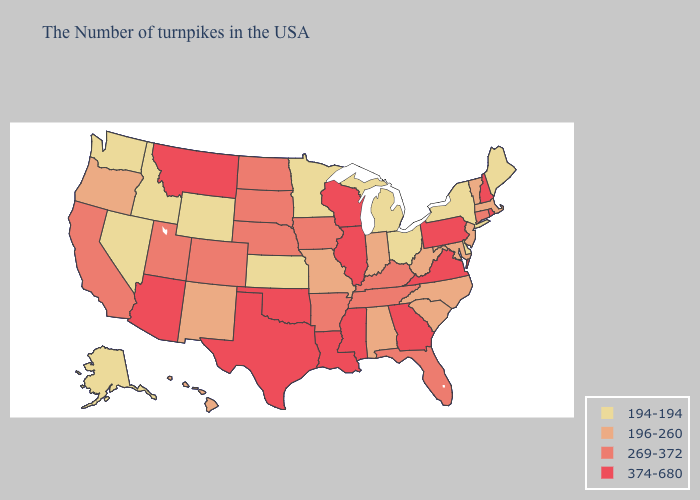Name the states that have a value in the range 269-372?
Short answer required. Connecticut, Florida, Kentucky, Tennessee, Arkansas, Iowa, Nebraska, South Dakota, North Dakota, Colorado, Utah, California. Does New Jersey have the highest value in the Northeast?
Short answer required. No. Among the states that border Oregon , does Idaho have the highest value?
Concise answer only. No. What is the highest value in the MidWest ?
Answer briefly. 374-680. Does South Carolina have a higher value than Nevada?
Answer briefly. Yes. Name the states that have a value in the range 196-260?
Be succinct. Massachusetts, Vermont, New Jersey, Maryland, North Carolina, South Carolina, West Virginia, Indiana, Alabama, Missouri, New Mexico, Oregon, Hawaii. What is the highest value in states that border Utah?
Answer briefly. 374-680. What is the value of Missouri?
Be succinct. 196-260. What is the value of Ohio?
Quick response, please. 194-194. What is the highest value in the MidWest ?
Short answer required. 374-680. Does Connecticut have a lower value than Rhode Island?
Give a very brief answer. Yes. Among the states that border Maryland , does West Virginia have the highest value?
Short answer required. No. Name the states that have a value in the range 374-680?
Write a very short answer. Rhode Island, New Hampshire, Pennsylvania, Virginia, Georgia, Wisconsin, Illinois, Mississippi, Louisiana, Oklahoma, Texas, Montana, Arizona. What is the value of Minnesota?
Write a very short answer. 194-194. How many symbols are there in the legend?
Concise answer only. 4. 